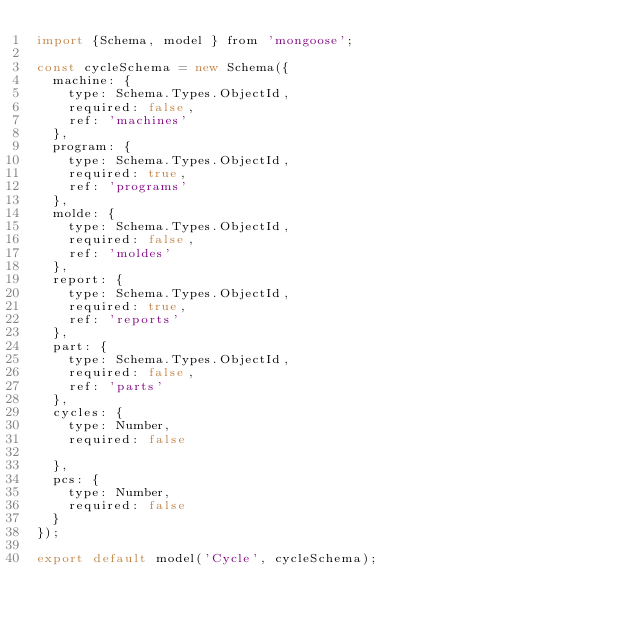<code> <loc_0><loc_0><loc_500><loc_500><_JavaScript_>import {Schema, model } from 'mongoose';

const cycleSchema = new Schema({
  machine: {
    type: Schema.Types.ObjectId,
    required: false,
    ref: 'machines'
  },
  program: {
    type: Schema.Types.ObjectId,
    required: true,
    ref: 'programs'
  },
  molde: {
    type: Schema.Types.ObjectId,
    required: false,
    ref: 'moldes'
  },
  report: {
    type: Schema.Types.ObjectId,
    required: true,
    ref: 'reports'
  },
  part: {
    type: Schema.Types.ObjectId,
    required: false,
    ref: 'parts'
  },
  cycles: {
    type: Number,
    required: false
    
  },
  pcs: {
    type: Number,
    required: false
  }
});

export default model('Cycle', cycleSchema);</code> 